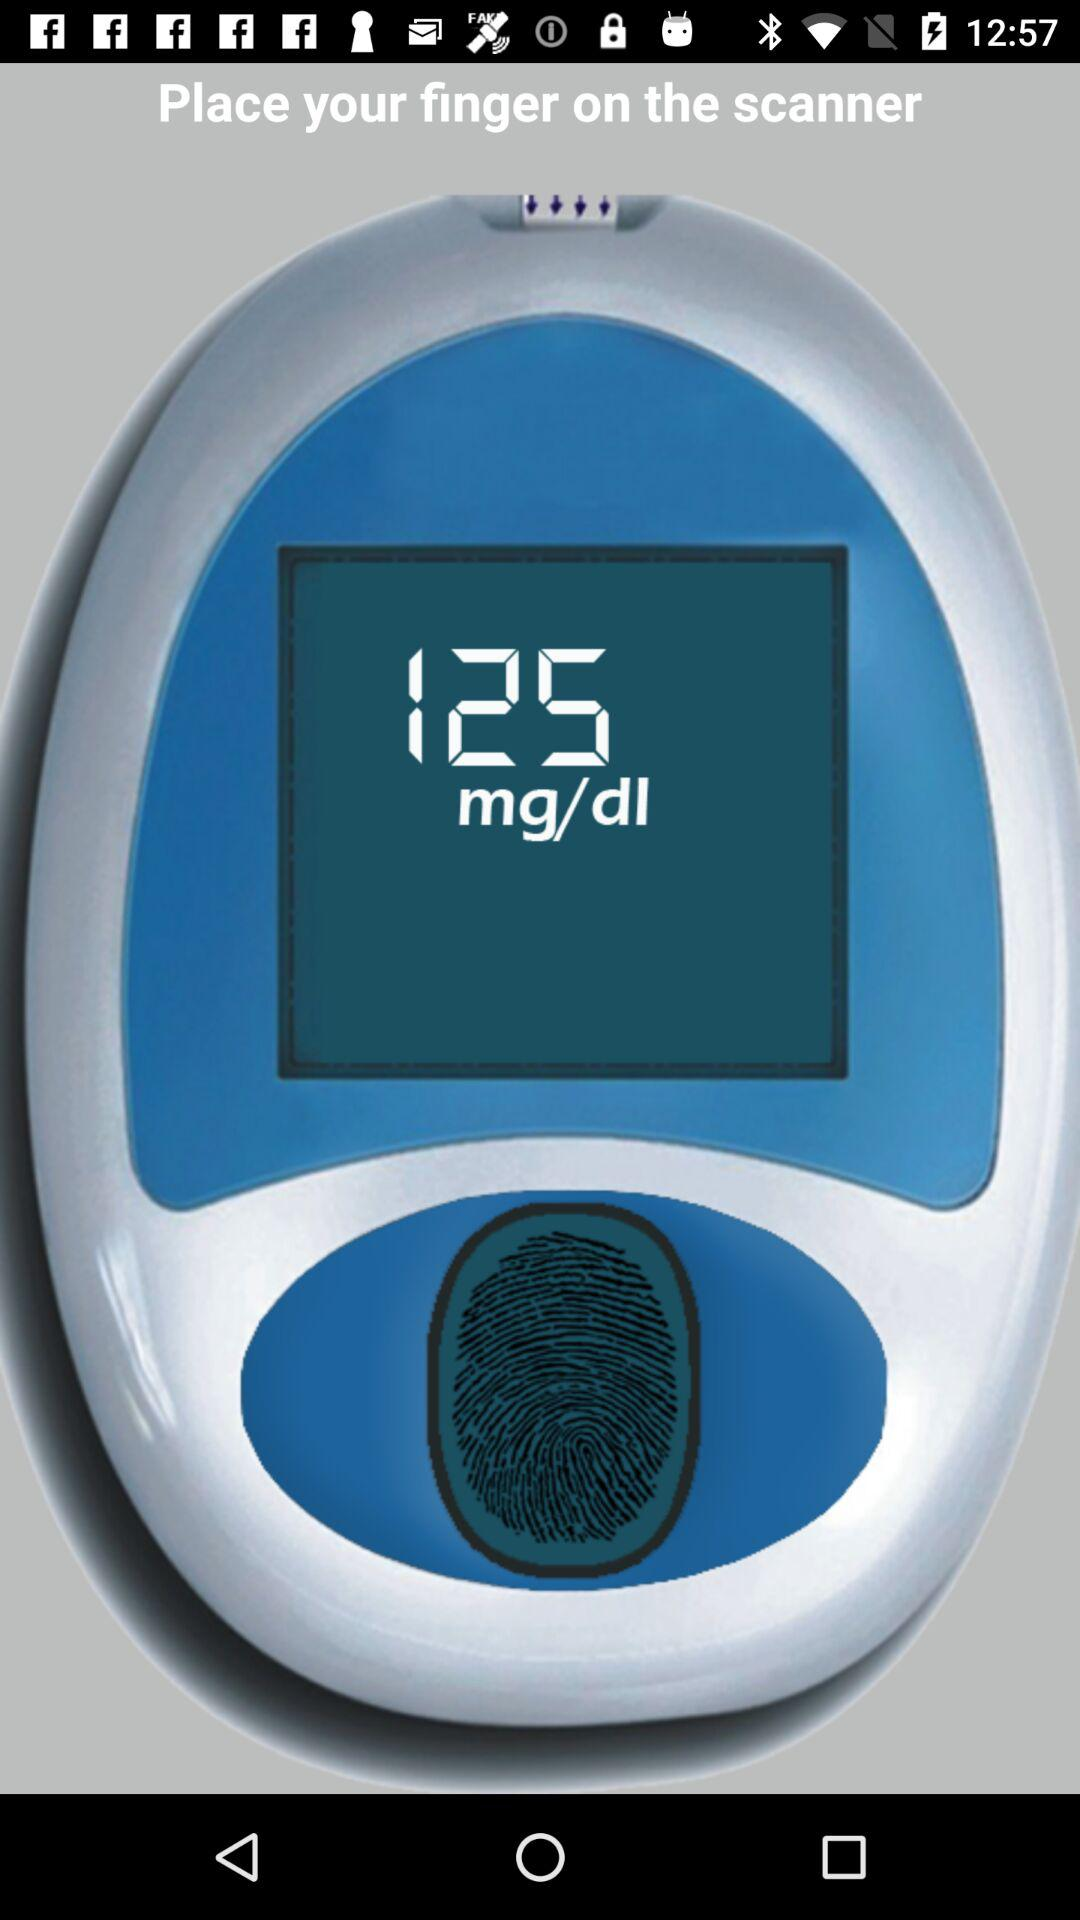What is the application name?
When the provided information is insufficient, respond with <no answer>. <no answer> 